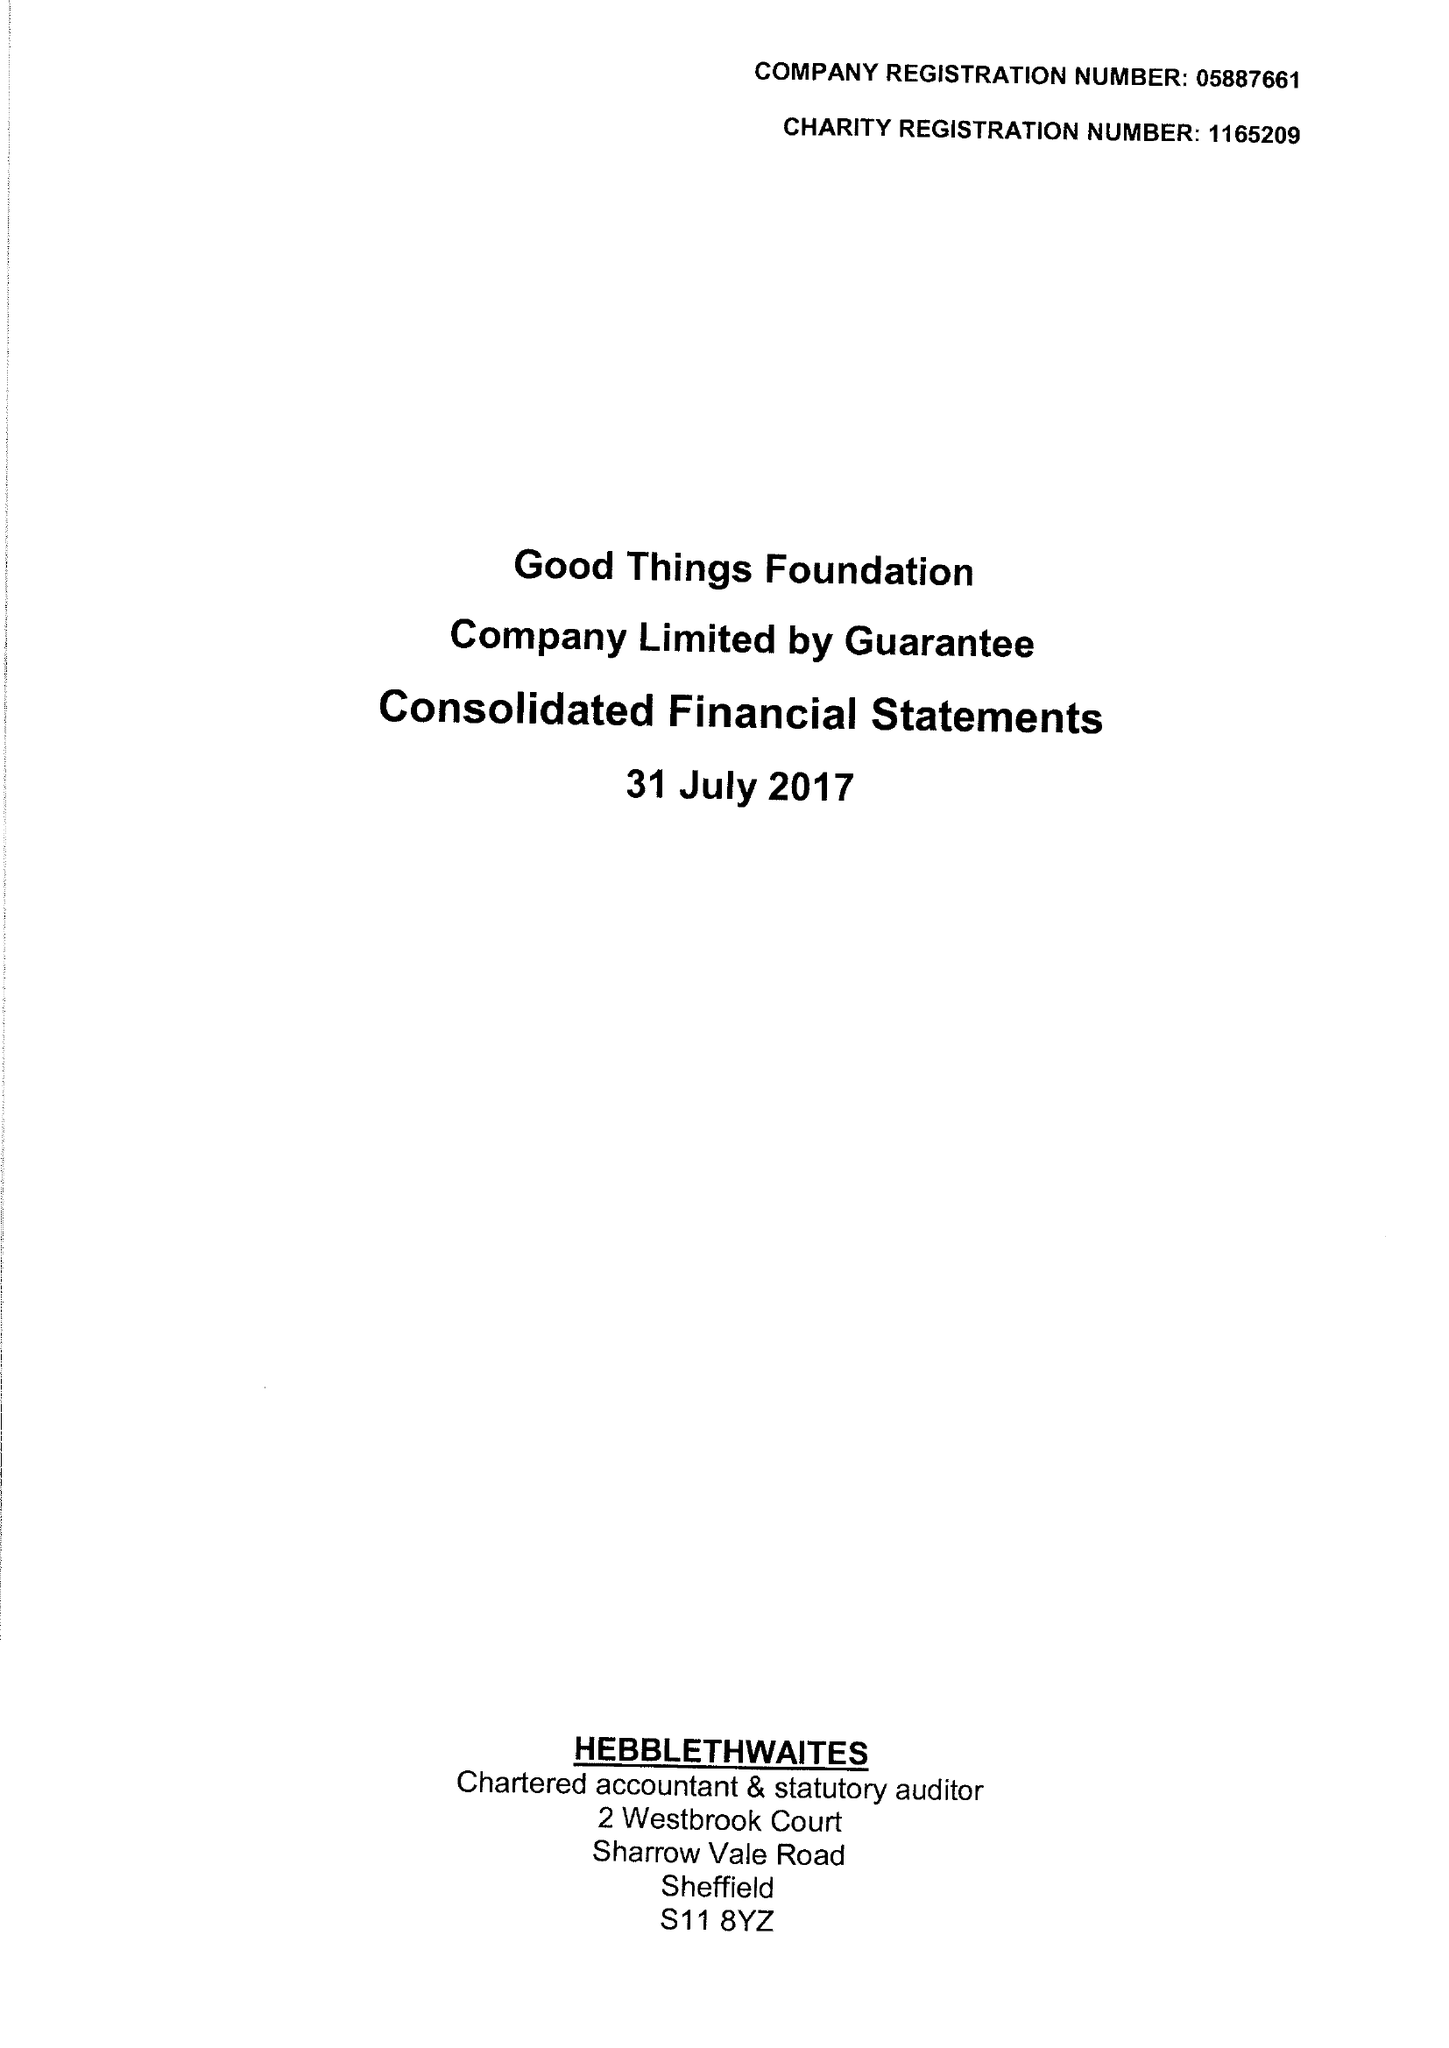What is the value for the spending_annually_in_british_pounds?
Answer the question using a single word or phrase. 6510185.00 